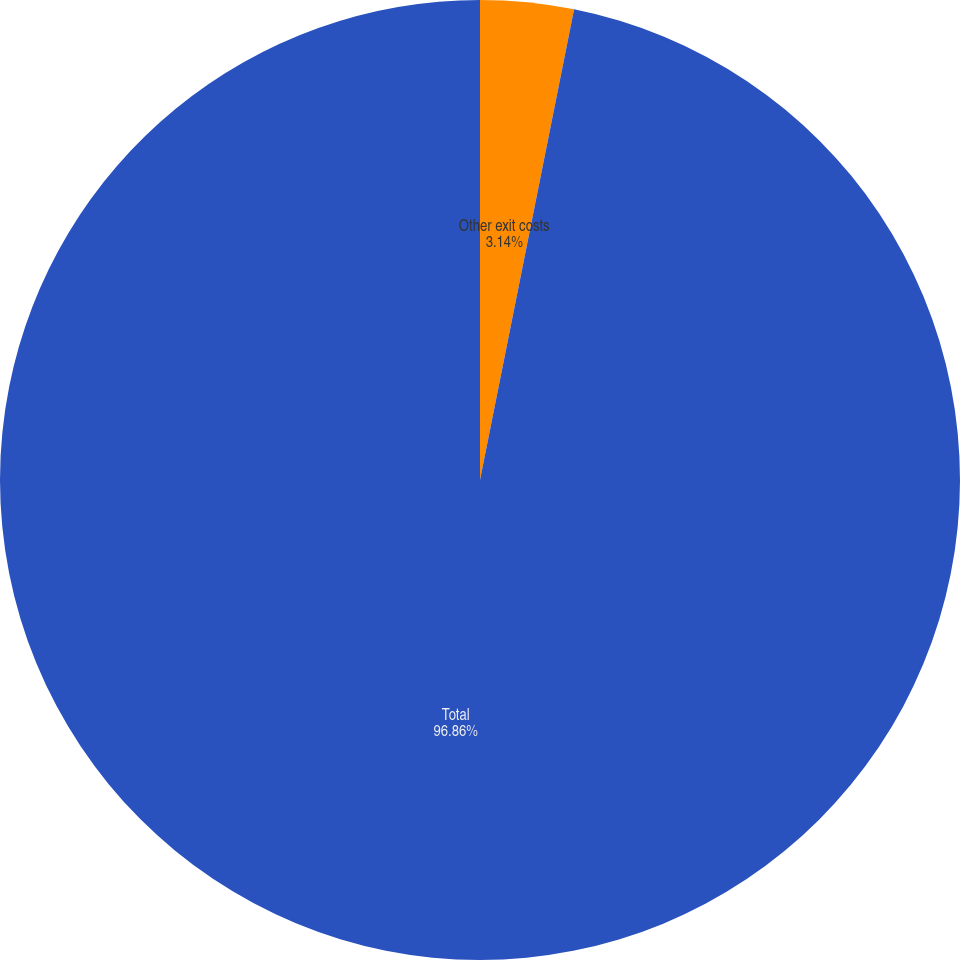Convert chart. <chart><loc_0><loc_0><loc_500><loc_500><pie_chart><fcel>Other exit costs<fcel>Total<nl><fcel>3.14%<fcel>96.86%<nl></chart> 